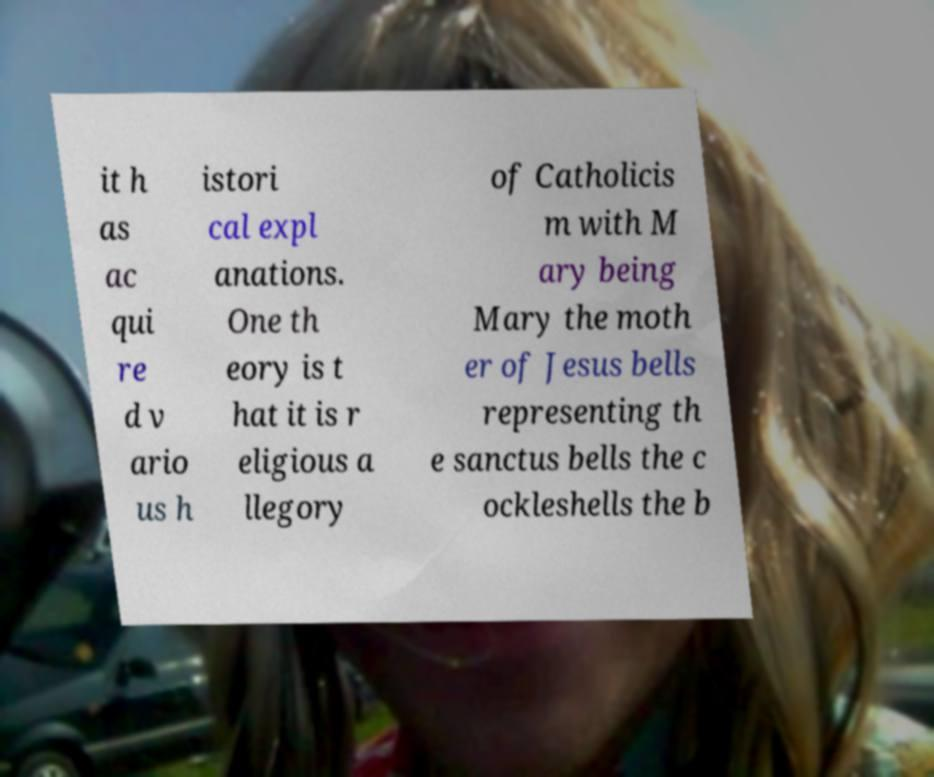Could you extract and type out the text from this image? it h as ac qui re d v ario us h istori cal expl anations. One th eory is t hat it is r eligious a llegory of Catholicis m with M ary being Mary the moth er of Jesus bells representing th e sanctus bells the c ockleshells the b 